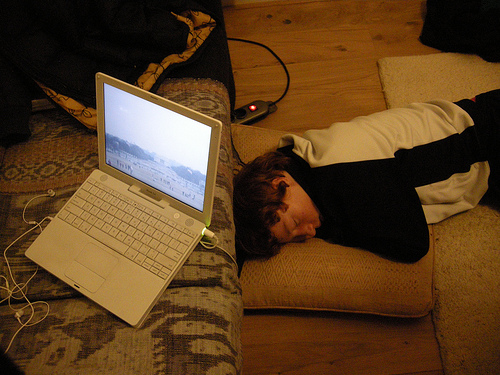<image>
Is the laptop above the man? Yes. The laptop is positioned above the man in the vertical space, higher up in the scene. 